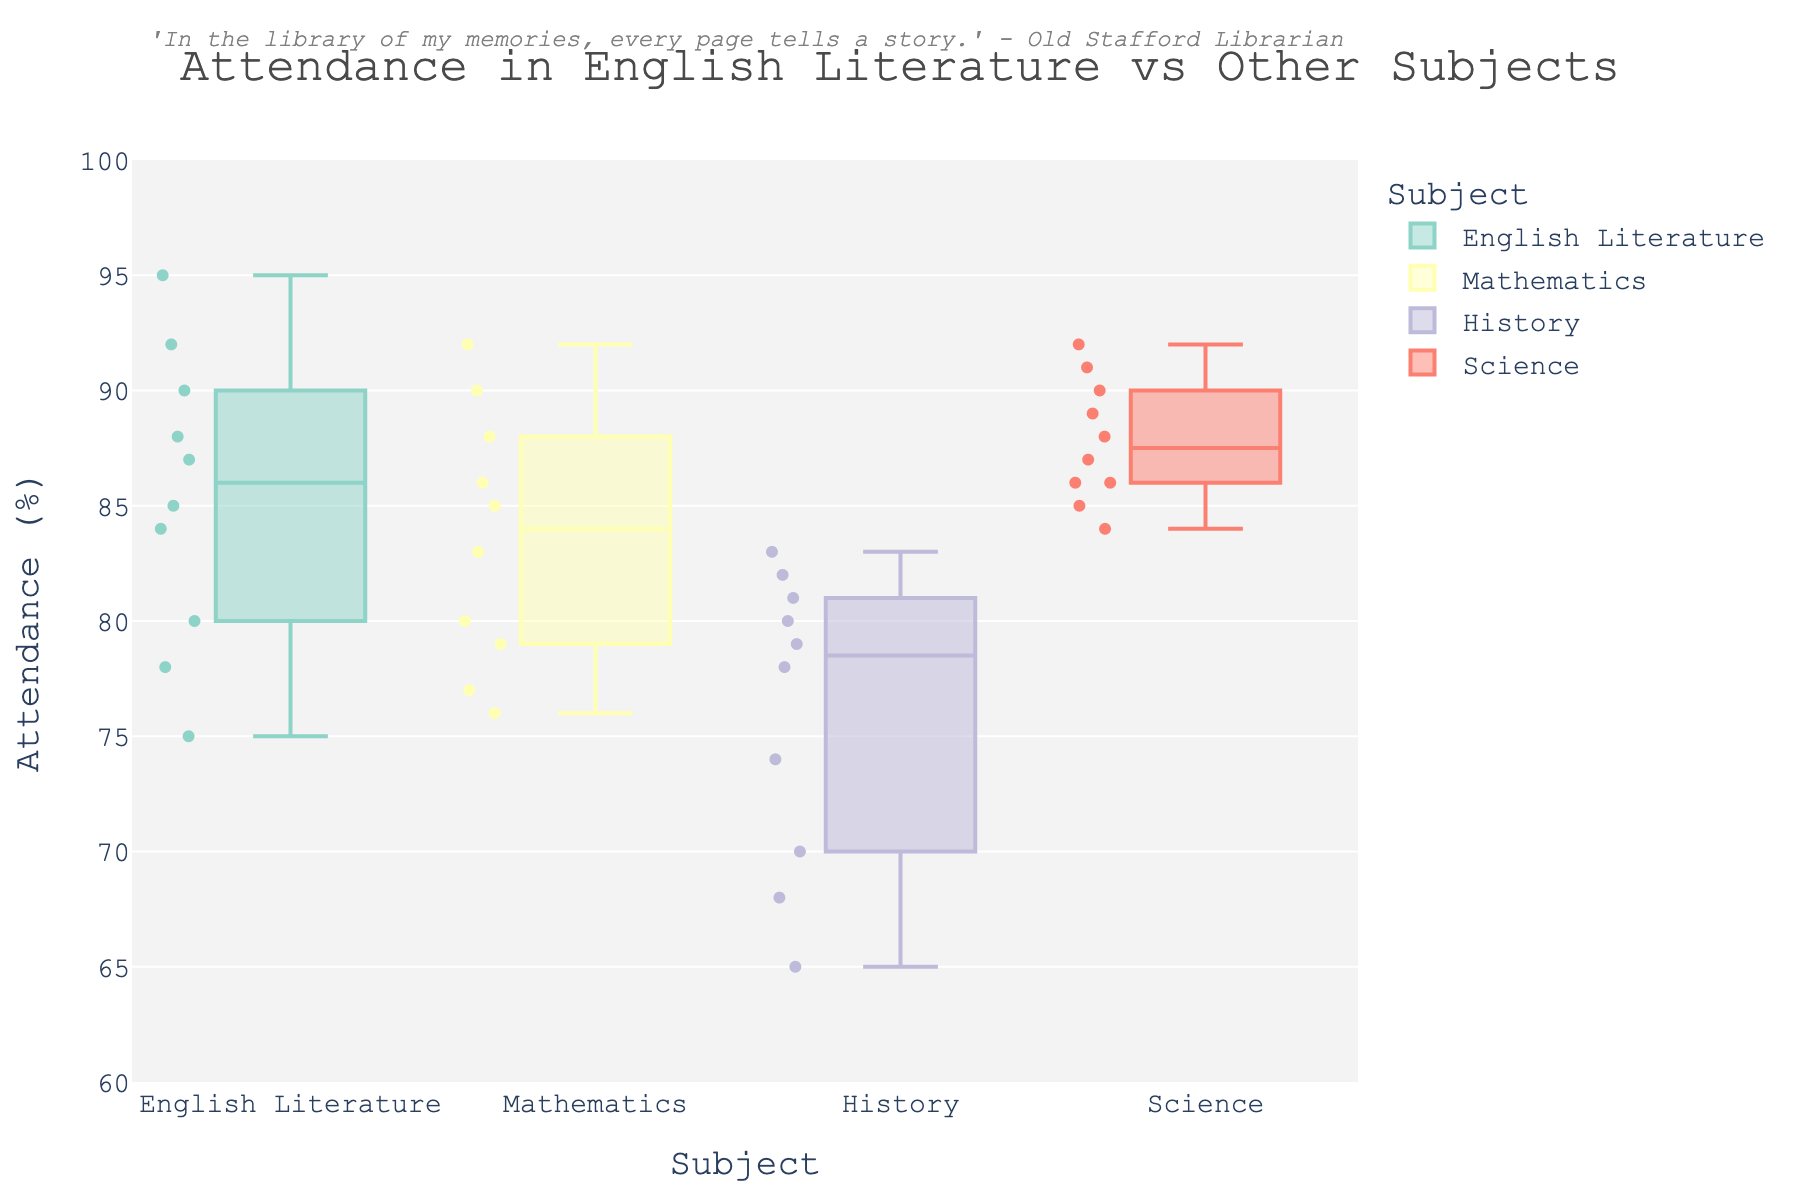What's the title of the figure? The title of the figure is displayed in the top center part of the plot, often serving as a summary of the plotted data.
Answer: Attendance in English Literature vs Other Subjects Which subject shows the highest maximum attendance? Each box plot has whiskers that extend to the maximum value points. By looking at the upper whisker, we can see which subject has the highest maximum attendance. Science has the whisker extending to 92%.
Answer: Science What is the median attendance for English Literature? The median is the line inside the box of each box plot. For English Literature, this line is located at 87.5%.
Answer: 87.5% How many students attended the Mathematics classes? Scatter plots overlaid on the box plot show the raw data points. By counting these points for Mathematics, we see there are 10 data points.
Answer: 10 Which subject has the widest range of attendance values? The range is the difference between the maximum and minimum values (the ends of the whiskers). History shows the widest range, from 65 to 83, a range of 18%.
Answer: History What is the interquartile range (IQR) of Science attendance? The IQR is the range between the first quartile and the third quartile (the bottom and top of the box). For Science, the IQR is from 86 to 90.5, giving us an IQR of 4.5%.
Answer: 4.5% Which subject has the lowest minimum attendance? The minimum attendance is represented by the bottom whisker of each box plot. History has the lowest whisker at 65%.
Answer: History Compare the median attendance between Mathematics and History. Which one is higher? The median is represented by the line inside the box. By comparing the medians of Mathematics (85%) and History (78%), we see Mathematics has a higher median.
Answer: Mathematics Is the overall spread of attendance in English Literature broader or narrower compared to Mathematics? The spread can be assessed by comparing the distance between the maximum and minimum values (whiskers). English Literature ranges from 75 to 95 (20%), and Mathematics ranges from 76 to 92 (16%). Therefore, English Literature has a broader spread.
Answer: Broader What do the scatter points overlaid on the box plots represent? The scatter points represent individual student attendance data for the respective subjects, allowing for a more detailed view of the distribution within each subject.
Answer: Individual attendance data points 